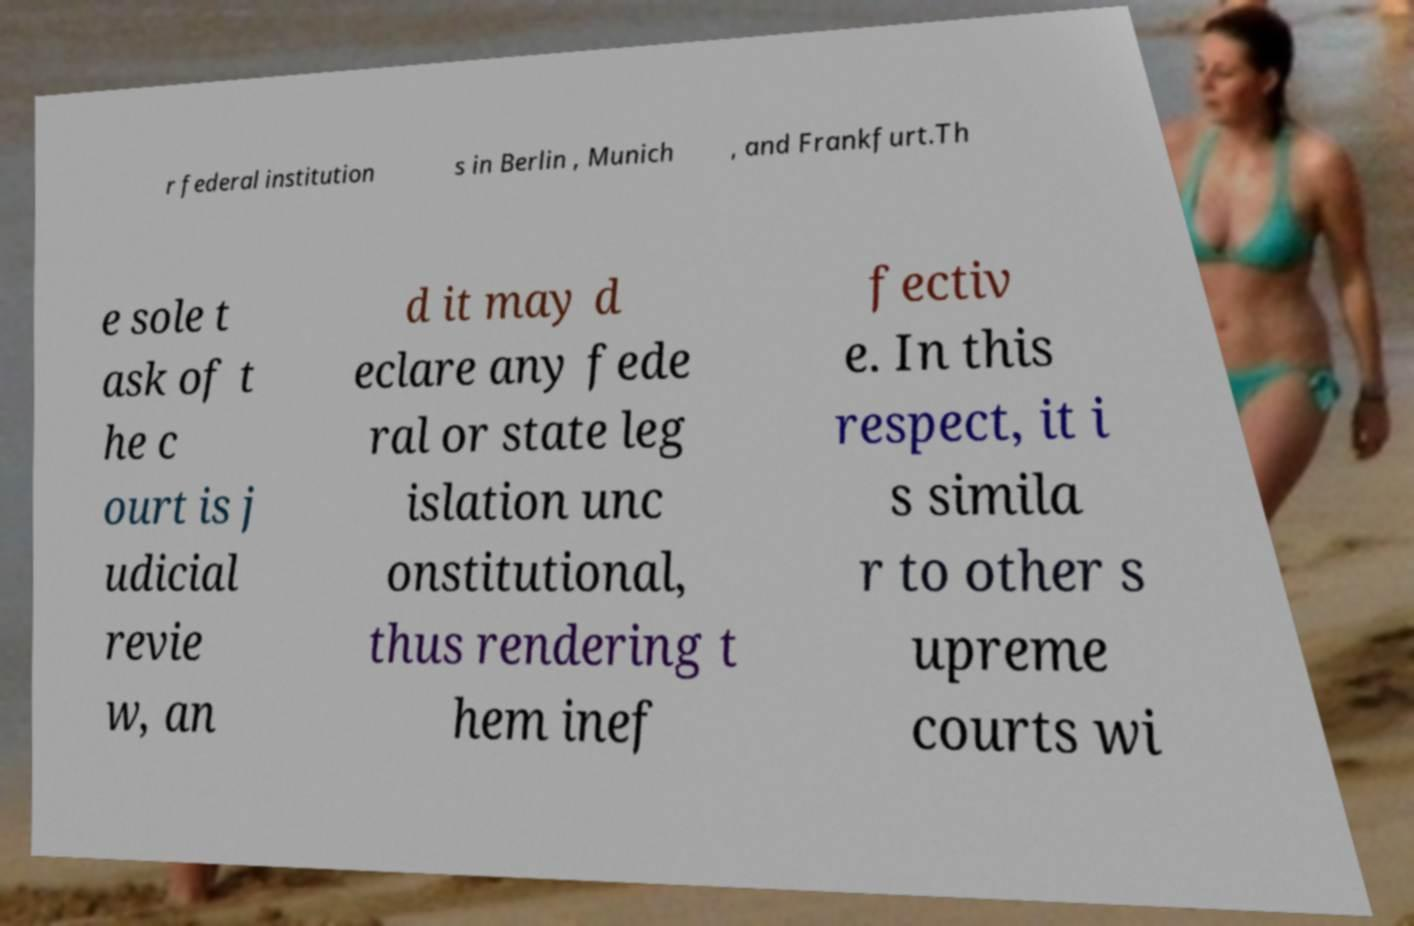For documentation purposes, I need the text within this image transcribed. Could you provide that? r federal institution s in Berlin , Munich , and Frankfurt.Th e sole t ask of t he c ourt is j udicial revie w, an d it may d eclare any fede ral or state leg islation unc onstitutional, thus rendering t hem inef fectiv e. In this respect, it i s simila r to other s upreme courts wi 